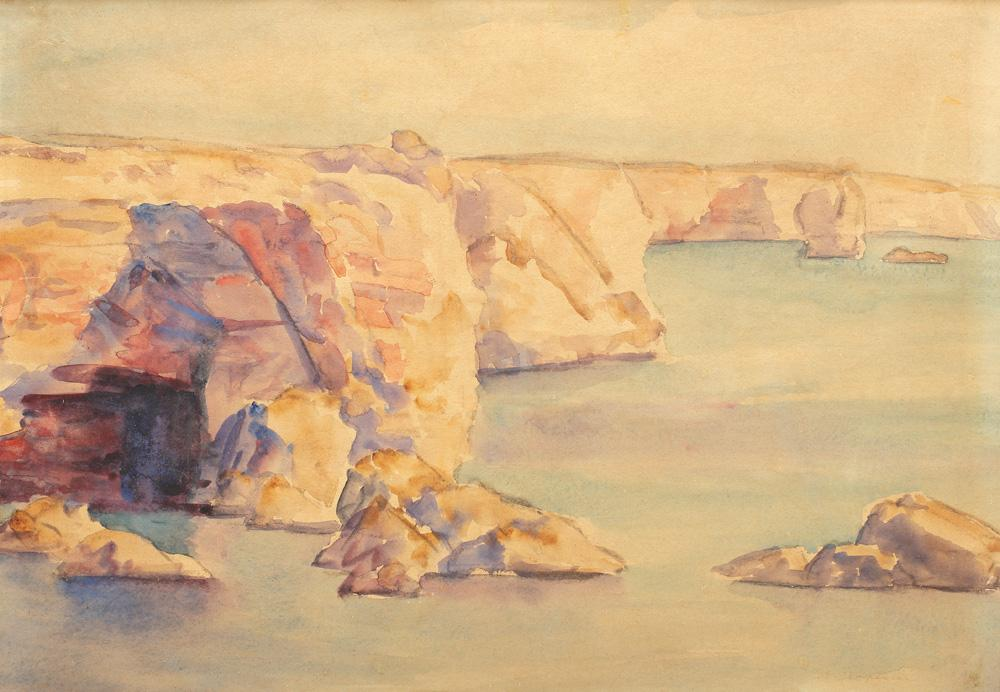Describe the striking features of this scene. The scene is characterized by its striking rocky coastline, where imposing cliffs dominate the landscape. These cliffs are artfully rendered with a palette of warm yellows, oranges, and reds, suggesting sunlight bathing their craggy surfaces. The smooth gradations of watercolor blend create a dynamic texture that brings the rocks to life. In contrast, the calm expanse of water below provides a serene counterbalance, with cool blue and green hues reflecting the sky. This interplay of warm and cool tones establishes a harmonious and visually compelling composition. This scene seems very peaceful. How could it be used in a film? In a film, this serene coastal scene could serve as an ideal location for pivotal moments of introspection or emotional resolution. Characters might retreat to this tranquil spot to contemplate their paths, find solace in the beauty of nature, or share meaningful conversations. It could be the setting for a heartfelt reconciliation, the start of a profound journey, or a place where secrets are revealed. The peaceful and majestic backdrop adds a layer of depth to these narrative moments, highlighting the characters' experiences against the timeless beauty of the coastline. Envision this place as part of a fantasy world. What role does it play? In a fantasy world, this rocky coastline could be the boundary of an ancient kingdom or the gateway to a mystical realm. Perhaps it is the dwelling place of a wise old hermit who possesses secret knowledge or a portal through which only the brave can pass to discover magical lands. The cliffs could be enchanted, with glowing runes that light up under certain conditions, guiding adventurers on their quests. The waters might house mythical creatures that guard precious treasures or offer aid to those who seek their counsel. This location could be pivotal in quests, harboring hidden paths and revelations crucial to the fantasy narrative. 